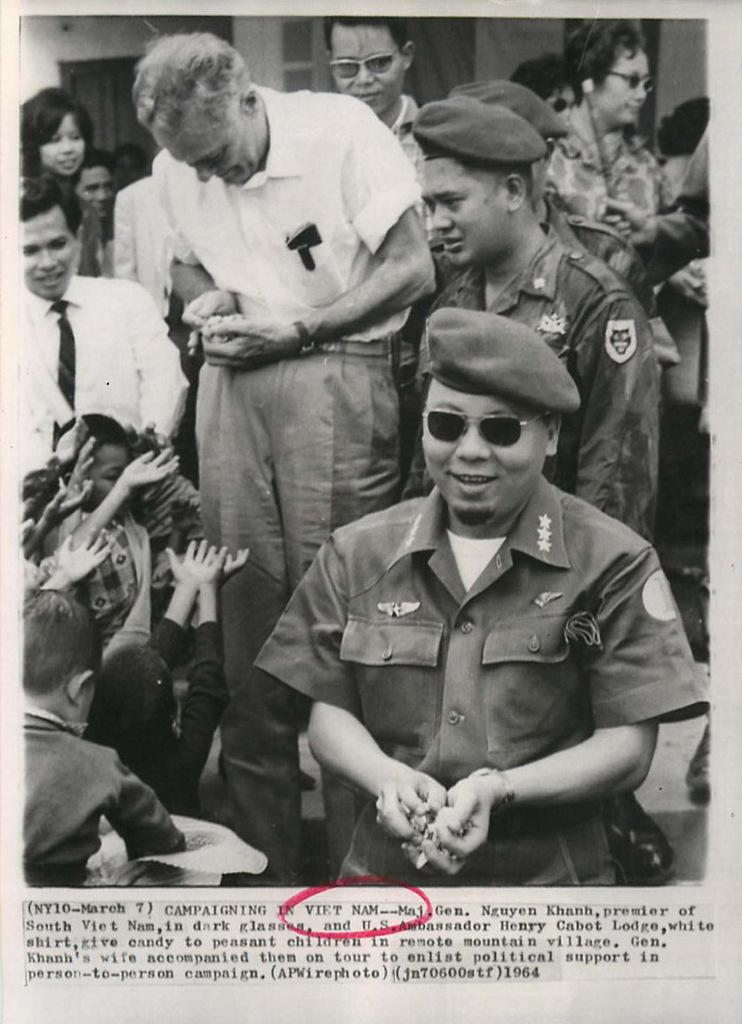Who or what is present in the image? There are people in the image. What are the people doing in the image? The people are smiling. What can be seen in the distance in the image? There is a building in the background of the image. What additional information is provided at the bottom of the image? There is some text at the bottom of the image. What type of cabbage is being kicked in the image? There is no cabbage or kicking activity present in the image. What number is associated with the people in the image? The provided facts do not mention any numbers associated with the people in the image. 